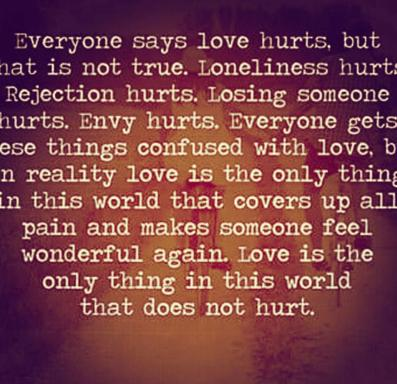What is the background of the image like and does it have any objects besides the text? The image features a striking background with soothing purple and brown hues setting a reflective mood. Accompanying the insightful text is a delicate butterfly, symbolizing transformation and hope, enhancing the message being conveyed about love. 